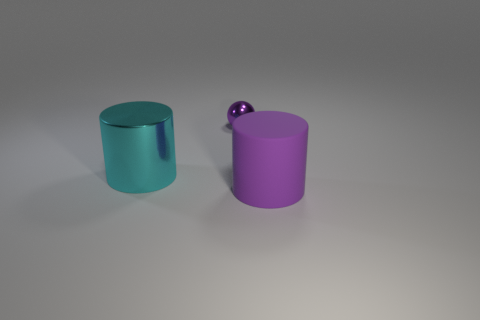Can you speculate on the scale of these objects? Without familiar objects to provide context, the absolute scale of these objects is challenging to determine. However, the smooth shadows and soft edges suggest they might not be very large, potentially the size of common household containers or decorative items. 